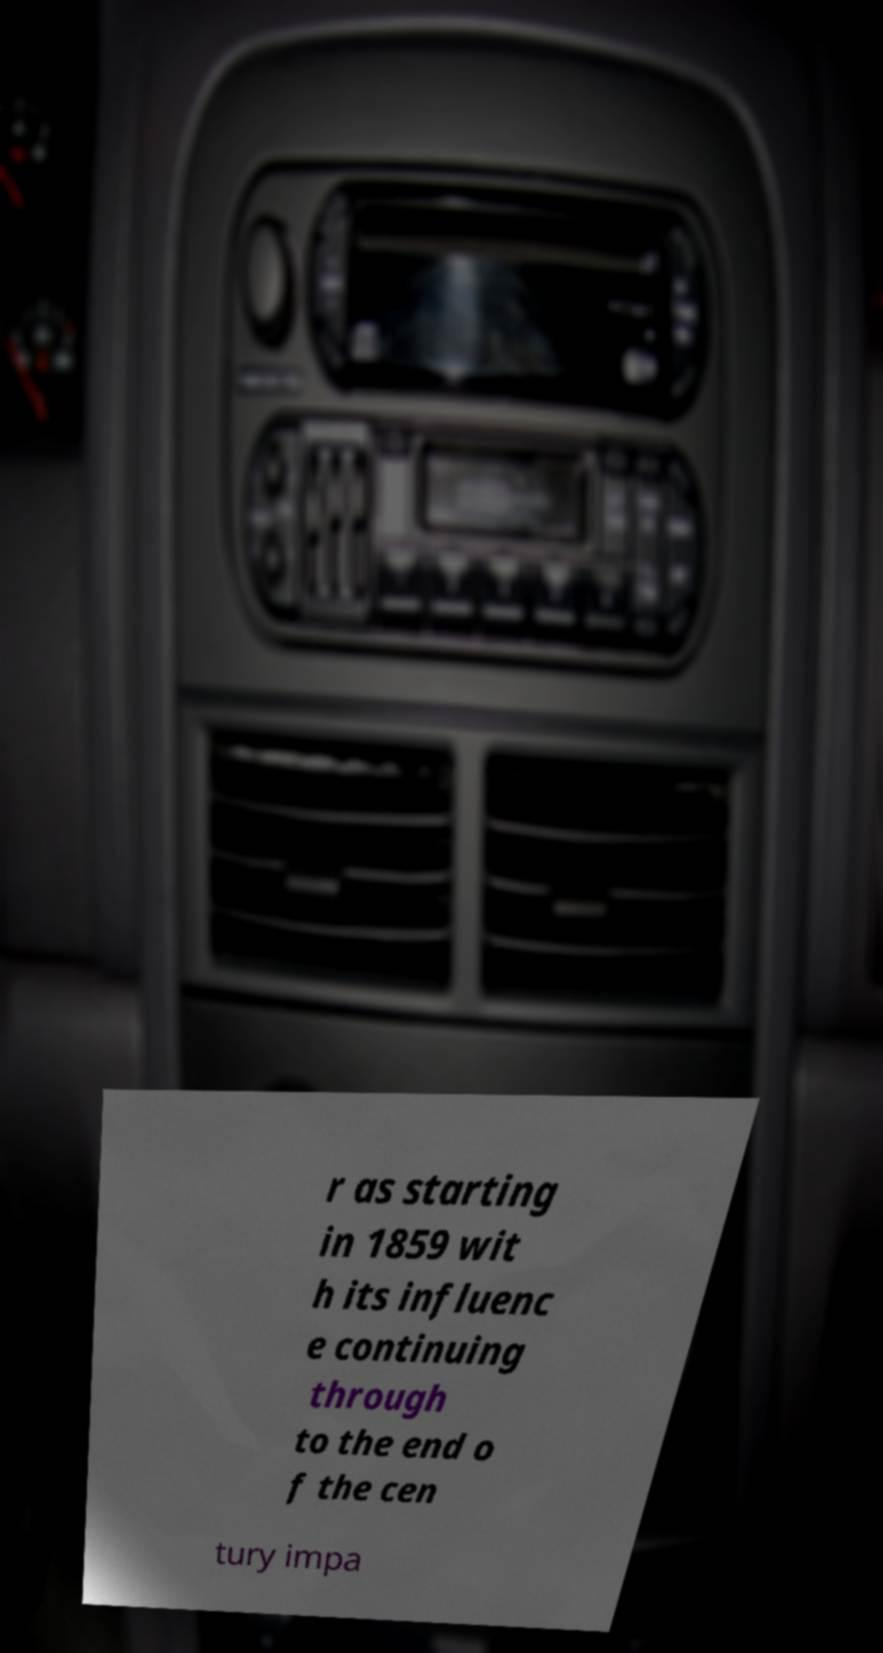Could you extract and type out the text from this image? r as starting in 1859 wit h its influenc e continuing through to the end o f the cen tury impa 